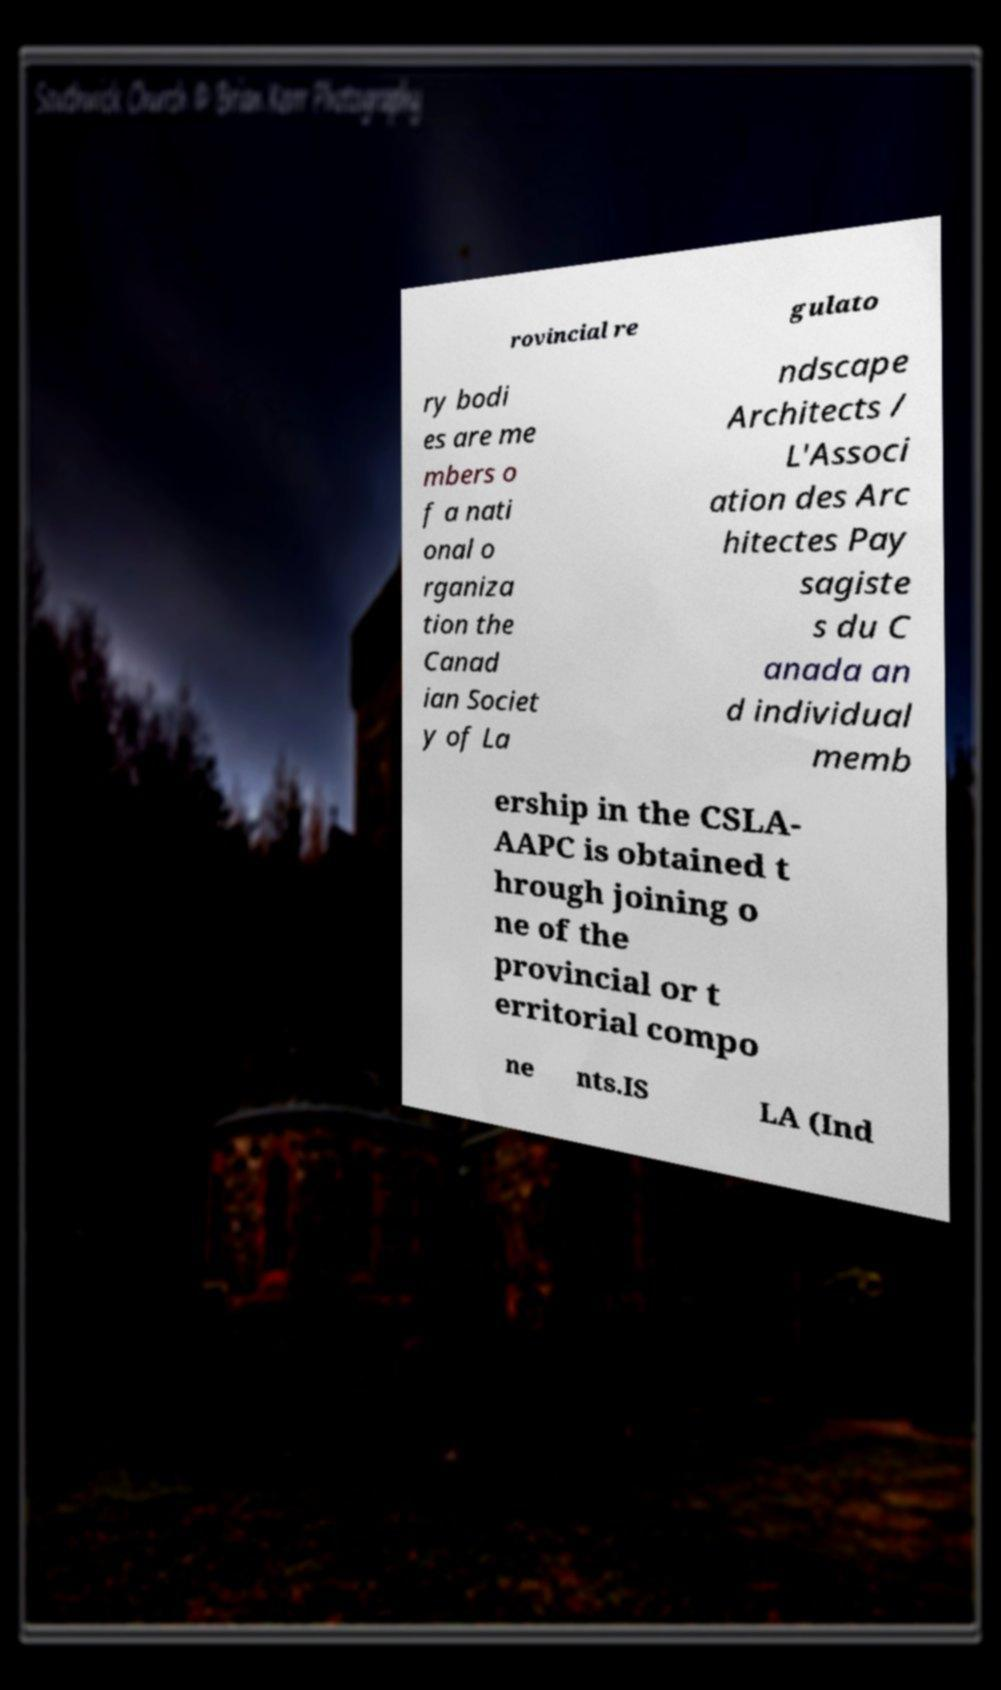I need the written content from this picture converted into text. Can you do that? rovincial re gulato ry bodi es are me mbers o f a nati onal o rganiza tion the Canad ian Societ y of La ndscape Architects / L'Associ ation des Arc hitectes Pay sagiste s du C anada an d individual memb ership in the CSLA- AAPC is obtained t hrough joining o ne of the provincial or t erritorial compo ne nts.IS LA (Ind 